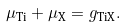<formula> <loc_0><loc_0><loc_500><loc_500>\mu _ { \text {Ti} } + \mu _ { \text {X} } = g _ { \text {TiX} } .</formula> 